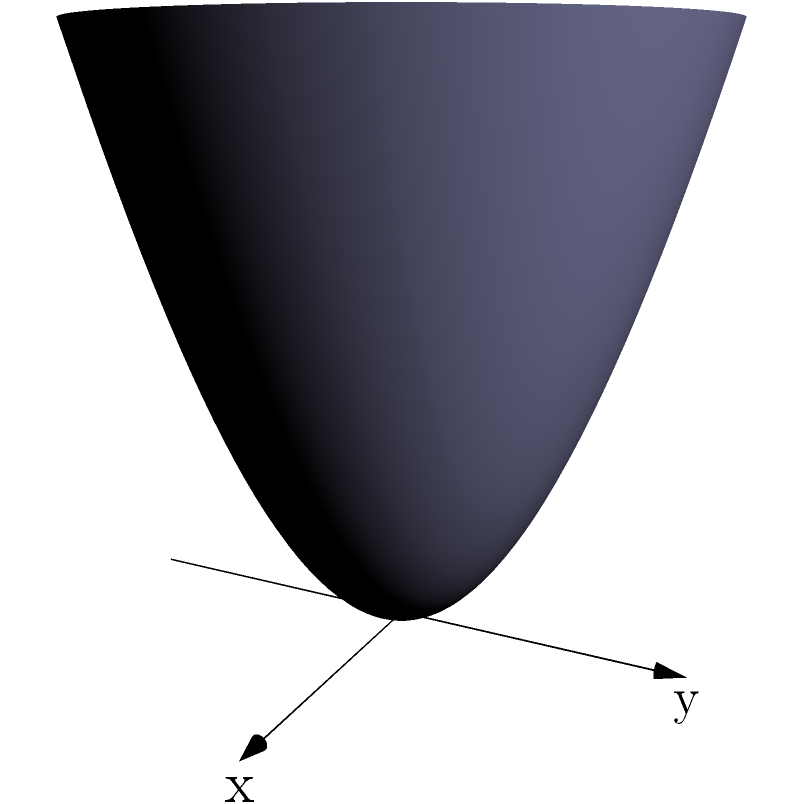Consider the solid object shown in the figure, which is formed by rotating the curve $z = x^2$ around the z-axis from $x = 0$ to $x = 2$. Determine the surface area of this object using integral calculus. To find the surface area of this rotational solid, we'll follow these steps:

1) The curve being rotated is $z = x^2$ from $x = 0$ to $x = 2$.

2) For a surface of revolution, the surface area is given by:

   $$A = 2\pi \int_a^b y \sqrt{1 + (\frac{dz}{dx})^2} dx$$

   where $y$ is the distance from the axis of rotation.

3) In our case, $y = x$ (distance from z-axis), and $\frac{dz}{dx} = 2x$.

4) Substituting into the formula:

   $$A = 2\pi \int_0^2 x \sqrt{1 + (2x)^2} dx$$

5) Simplify under the square root:

   $$A = 2\pi \int_0^2 x \sqrt{1 + 4x^2} dx$$

6) This integral is challenging to solve directly. We can use the substitution $u = 1 + 4x^2$:

   $du = 8x dx$
   $x dx = \frac{1}{8} du$

7) Changing the limits: when $x = 0$, $u = 1$; when $x = 2$, $u = 17$

8) Rewriting the integral:

   $$A = 2\pi \int_1^{17} \frac{\sqrt{u}}{8} \cdot \frac{1}{4}\sqrt{u-1} du$$

   $$A = \frac{\pi}{16} \int_1^{17} \sqrt{u(u-1)} du$$

9) This can be solved using the formula:

   $$\int \sqrt{u(u-1)} du = \frac{1}{3}(u-1)\sqrt{u(u-1)} + \frac{1}{3}\ln(u-1+\sqrt{u(u-1)}) + C$$

10) Evaluating at the limits and simplifying:

    $$A = \frac{\pi}{16} [\frac{16}{3}\sqrt{272} + \frac{1}{3}\ln(16+\sqrt{272}) - 0]$$

11) Simplifying further:

    $$A = \frac{\pi}{3}[16\sqrt{17} + \ln(16+\sqrt{272})]$$

This is the surface area of the given solid.
Answer: $\frac{\pi}{3}[16\sqrt{17} + \ln(16+\sqrt{272})]$ 